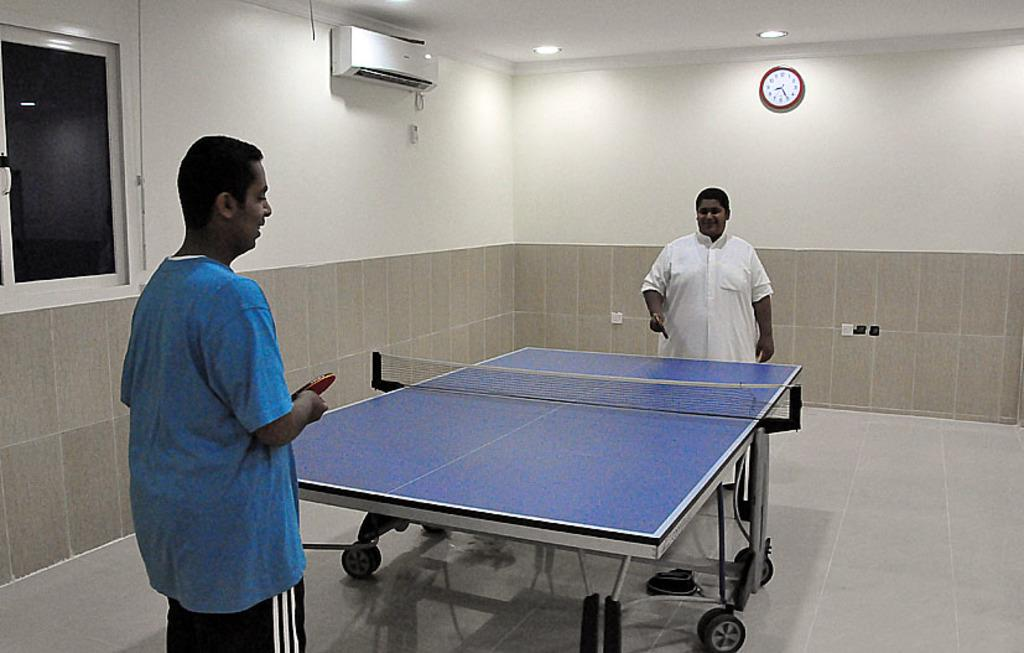How many people are in the image? There are two persons in the image. What are the persons holding in their hands? The persons are holding table tennis bats. What is in front of the persons? There is a table in front of the persons. What can be seen on the wall in the background? There is a watch and a clock on the wall in the background. What type of destruction is being caused by the spade in the image? There is no spade present in the image, and therefore no destruction can be observed. What kind of toy is being played with by the persons in the image? The persons are holding table tennis bats, not toys, in the image. 